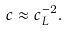<formula> <loc_0><loc_0><loc_500><loc_500>c \approx c _ { L } ^ { - 2 } .</formula> 